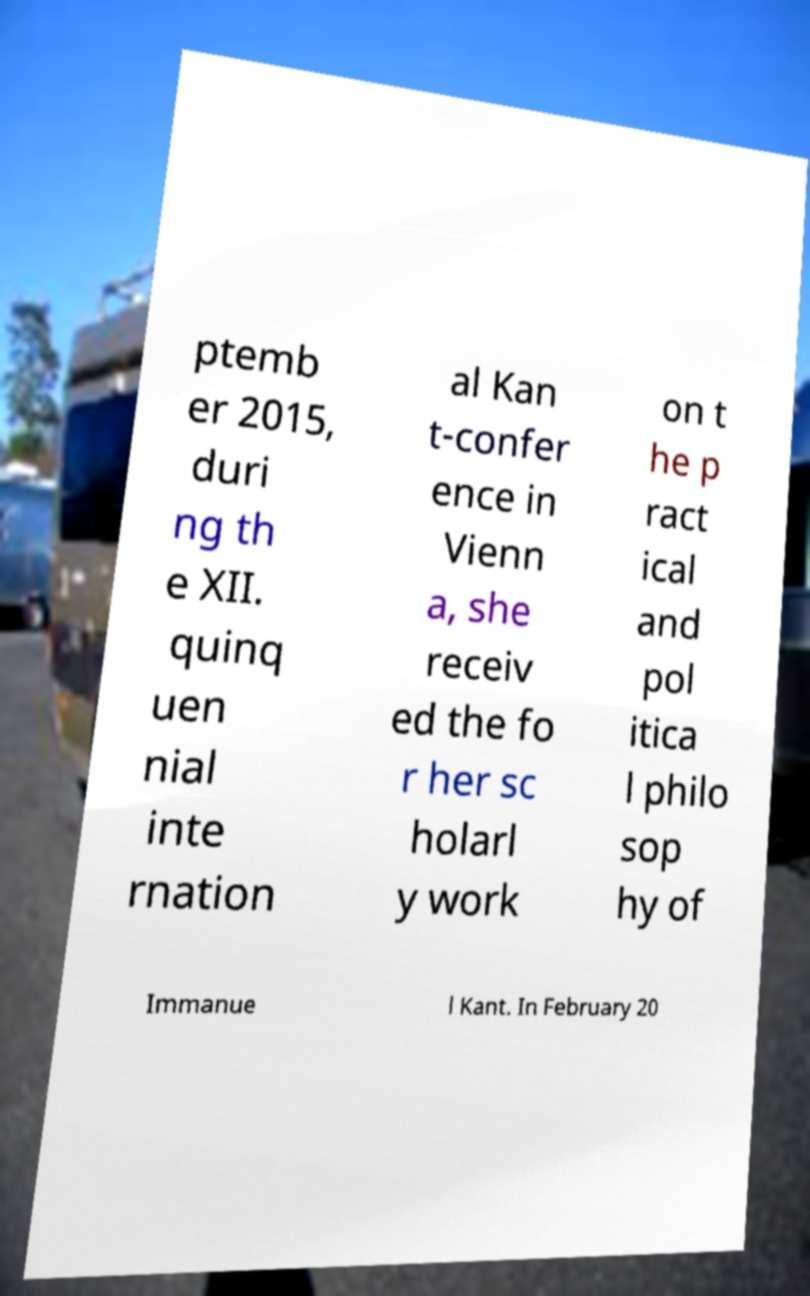There's text embedded in this image that I need extracted. Can you transcribe it verbatim? ptemb er 2015, duri ng th e XII. quinq uen nial inte rnation al Kan t-confer ence in Vienn a, she receiv ed the fo r her sc holarl y work on t he p ract ical and pol itica l philo sop hy of Immanue l Kant. In February 20 